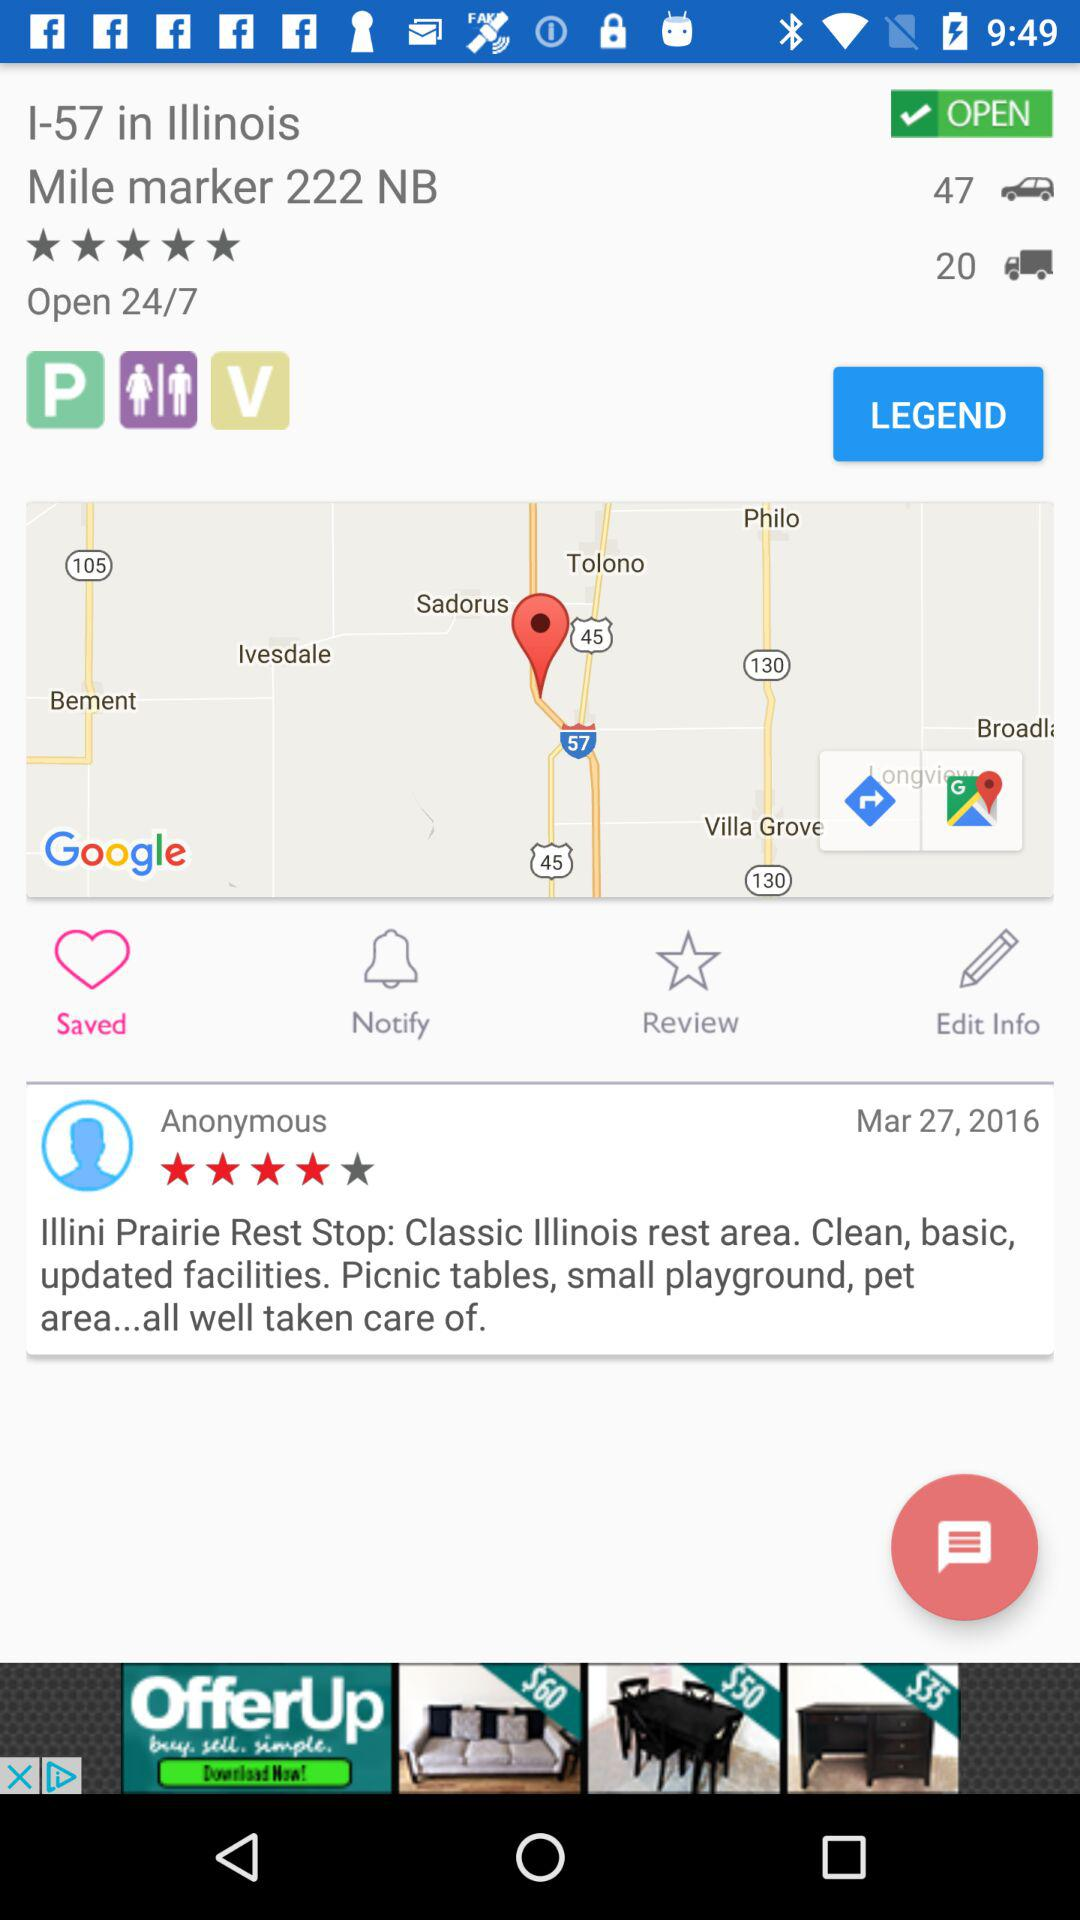How many heavy vehicles are there?
When the provided information is insufficient, respond with <no answer>. <no answer> 